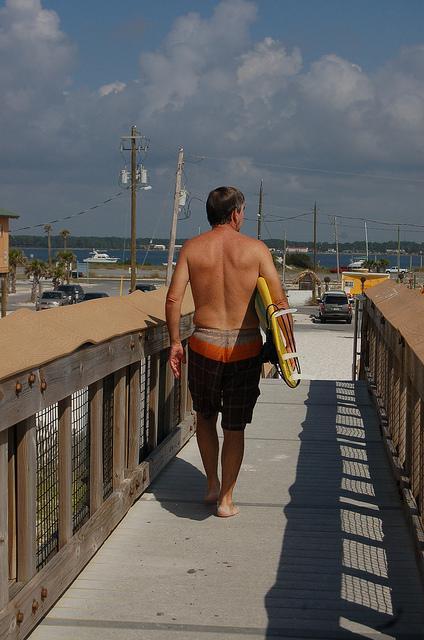How many sinks are there?
Give a very brief answer. 0. 